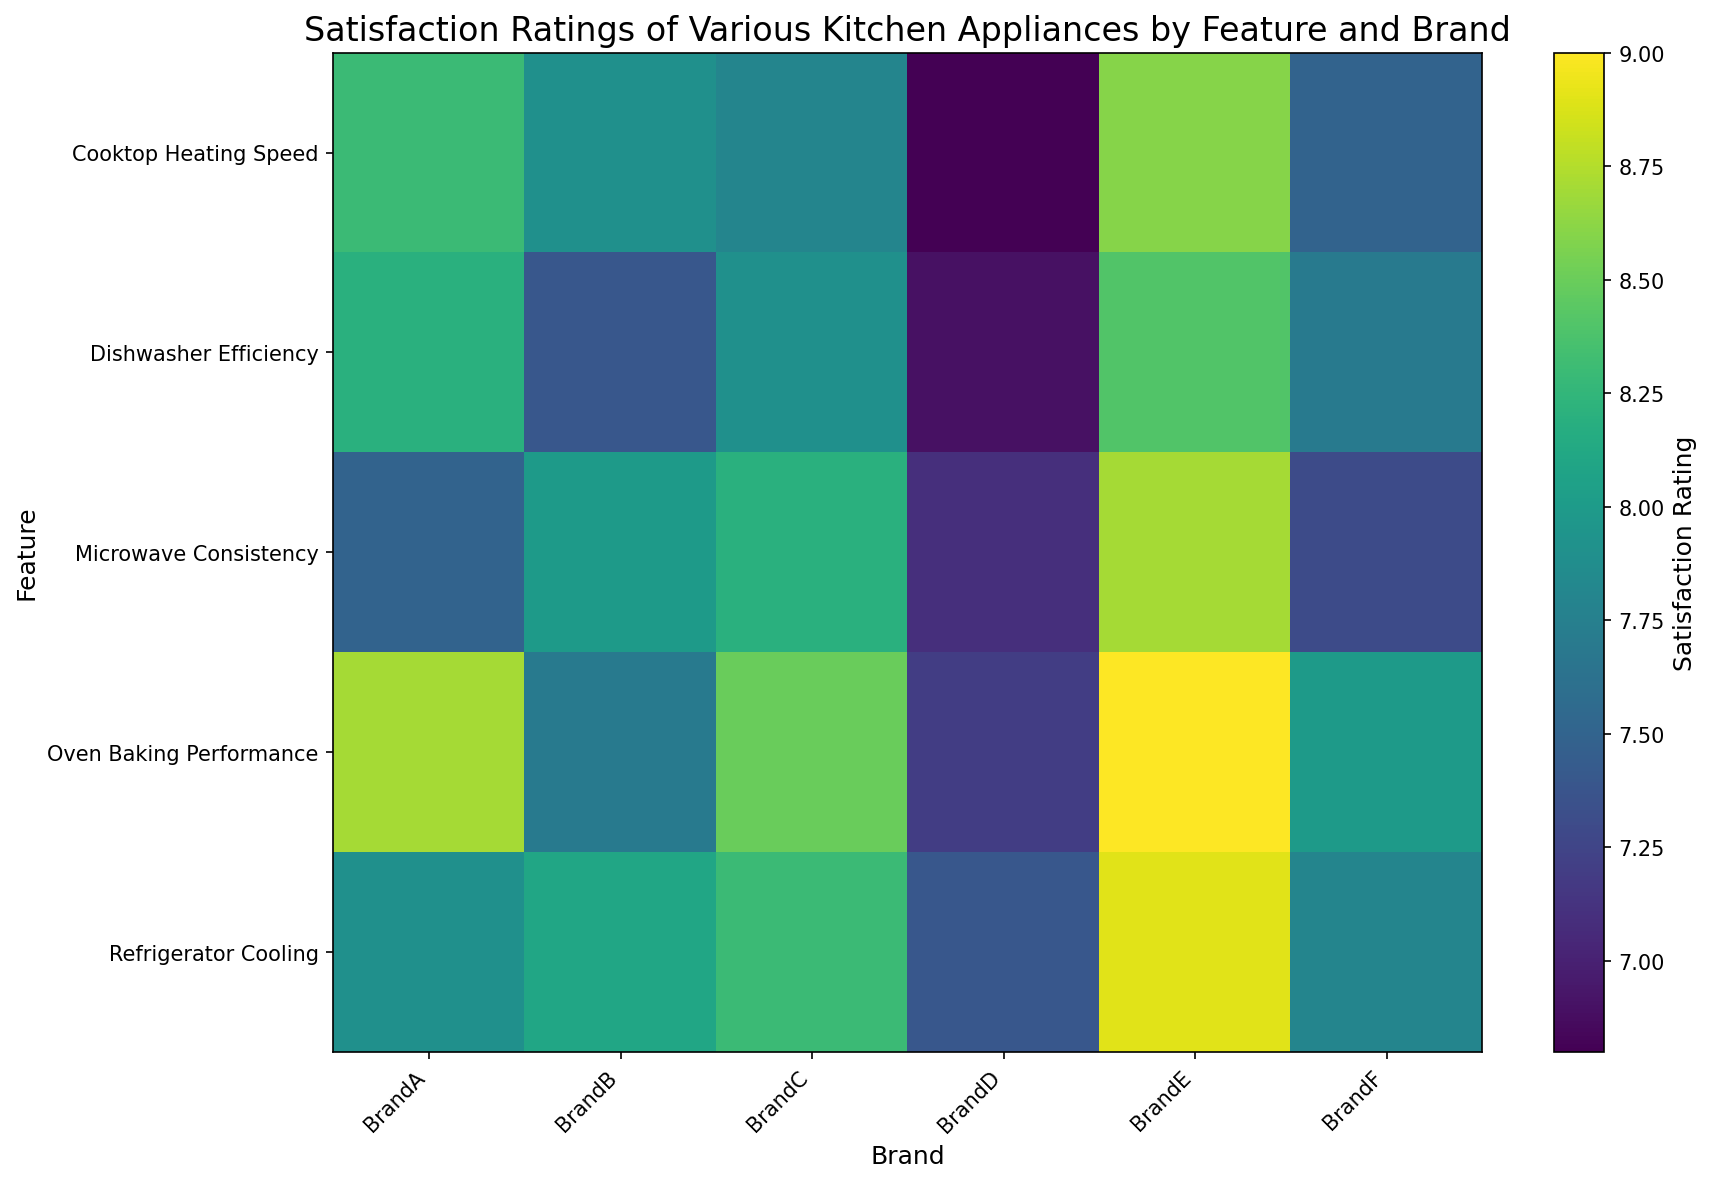Which brand has the highest satisfaction rating for refrigerator cooling? Look at the heatmap for the column representing refrigerator cooling and identify the brand with the darkest color shade in that row. In this case, Brand E has the highest rating.
Answer: Brand E Which kitchen appliance feature has the lowest satisfaction rating for Brand D? Look at the column for Brand D and identify the row with the lightest color shade, indicating the lowest rating. In this case, the cooktop heating speed has the lowest rating.
Answer: Cooktop Heating Speed What is the difference in satisfaction ratings for microwave consistency between Brand A and Brand B? Locate the microwave consistency row and compare the colors for Brand A and Brand B. Subtract the satisfaction rating of Brand B from Brand A (7.5 - 8.0).
Answer: -0.5 On average, how satisfied are users with Brand C's kitchen appliances? Find the ratings of all features for Brand C and calculate the average: (7.9 + 8.3 + 8.5 + 7.8 + 8.2) / 5 = 8.14
Answer: 8.14 Which brand has the most consistent satisfaction ratings across all features? Determine this by looking at each brand's column and identifying the one with the least variation in color shades. In this case, Brand F seems to have consistent ratings.
Answer: Brand F Among all brands, which feature has the highest overall satisfaction rating? Identify the darkest color shade in the entire heatmap. The darkest shade appears in Brand E's column for oven baking performance, with a rating of 9.0.
Answer: Oven Baking Performance How does Brand B's satisfaction for cooktop heating speed compare to Brand C's? Compare the colors for Brand B and Brand C in the cooktop heating speed row. Brand B has a rating of 7.9, while Brand C has 7.8, indicating they are very close.
Answer: Brand B's rating is slightly higher What is the average satisfaction rating for dishwasher efficiency across all brands? Sum the ratings for dishwasher efficiency across all brands and divide by the number of brands: (8.2 + 7.4 + 7.9 + 6.9 + 8.4 + 7.7) / 6 = 7.58
Answer: 7.58 